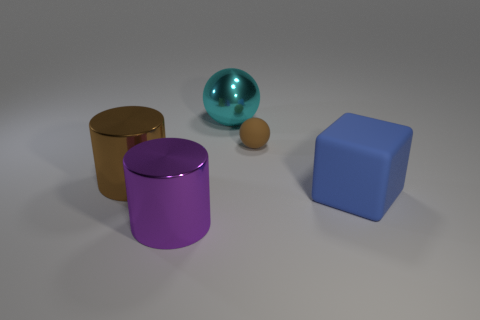Add 1 brown rubber cylinders. How many objects exist? 6 Subtract all cubes. How many objects are left? 4 Add 1 big cyan shiny balls. How many big cyan shiny balls are left? 2 Add 2 brown spheres. How many brown spheres exist? 3 Subtract 0 brown cubes. How many objects are left? 5 Subtract all large cyan metal balls. Subtract all small matte objects. How many objects are left? 3 